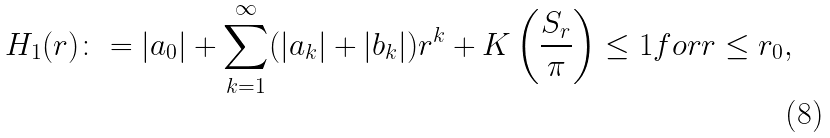Convert formula to latex. <formula><loc_0><loc_0><loc_500><loc_500>H _ { 1 } ( r ) \colon = | a _ { 0 } | + \sum _ { k = 1 } ^ { \infty } ( | a _ { k } | + | b _ { k } | ) r ^ { k } + K \left ( \frac { S _ { r } } { \pi } \right ) \leq 1 f o r r \leq r _ { 0 } ,</formula> 